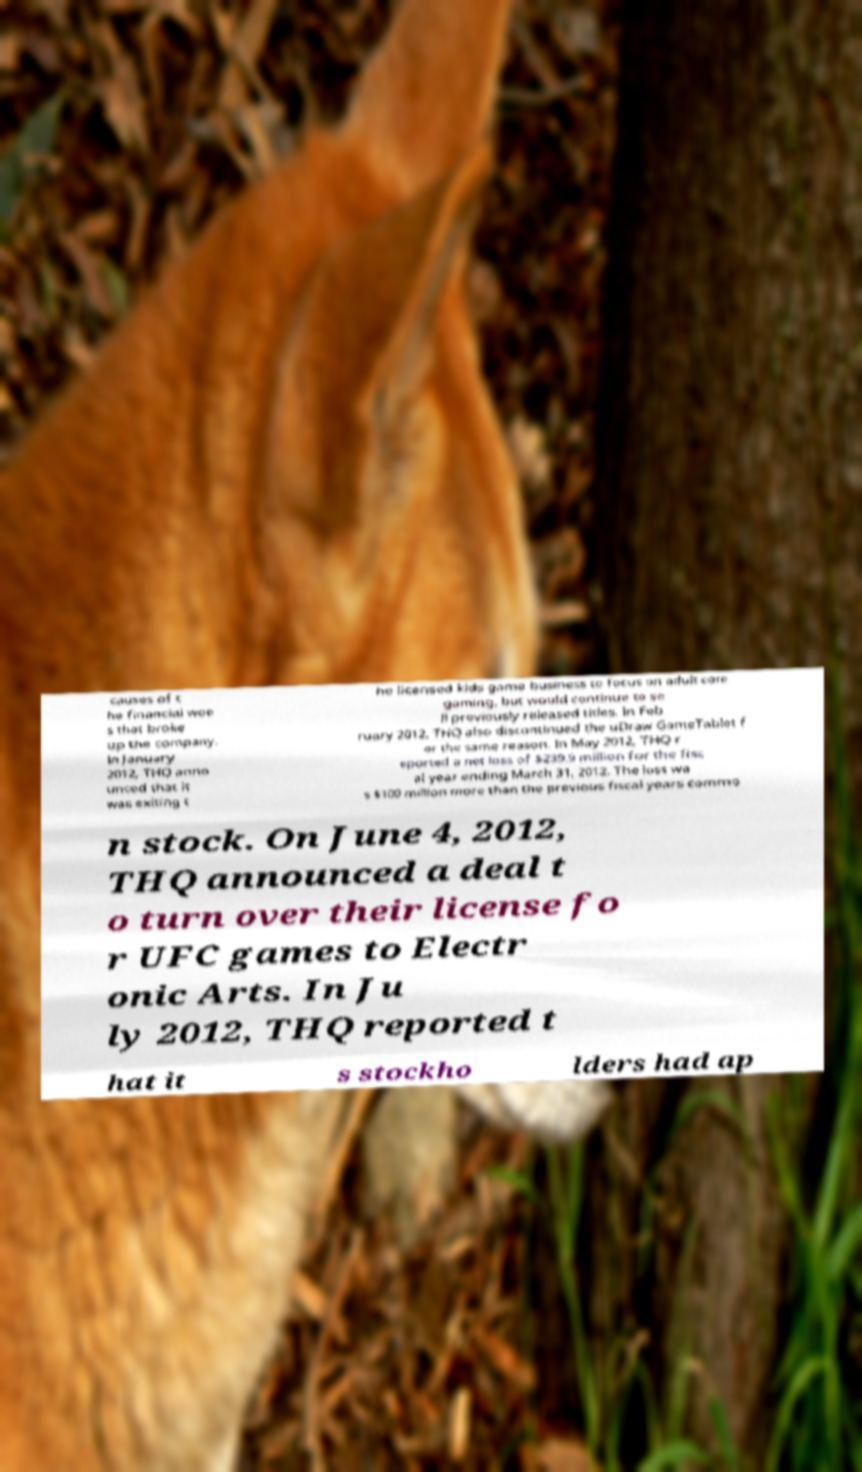For documentation purposes, I need the text within this image transcribed. Could you provide that? causes of t he financial woe s that broke up the company. In January 2012, THQ anno unced that it was exiting t he licensed kids game business to focus on adult core gaming, but would continue to se ll previously released titles. In Feb ruary 2012, THQ also discontinued the uDraw GameTablet f or the same reason. In May 2012, THQ r eported a net loss of $239.9 million for the fisc al year ending March 31, 2012. The loss wa s $100 million more than the previous fiscal years commo n stock. On June 4, 2012, THQ announced a deal t o turn over their license fo r UFC games to Electr onic Arts. In Ju ly 2012, THQ reported t hat it s stockho lders had ap 